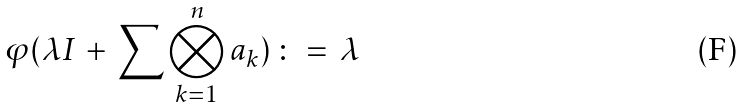<formula> <loc_0><loc_0><loc_500><loc_500>\varphi ( \lambda I \, + \, \sum \bigotimes _ { k = 1 } ^ { n } a _ { k } ) \, \colon = \, \lambda</formula> 